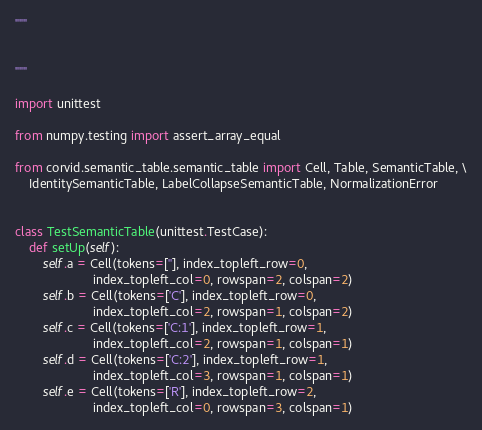<code> <loc_0><loc_0><loc_500><loc_500><_Python_>"""


"""

import unittest

from numpy.testing import assert_array_equal

from corvid.semantic_table.semantic_table import Cell, Table, SemanticTable, \
    IdentitySemanticTable, LabelCollapseSemanticTable, NormalizationError


class TestSemanticTable(unittest.TestCase):
    def setUp(self):
        self.a = Cell(tokens=[''], index_topleft_row=0,
                      index_topleft_col=0, rowspan=2, colspan=2)
        self.b = Cell(tokens=['C'], index_topleft_row=0,
                      index_topleft_col=2, rowspan=1, colspan=2)
        self.c = Cell(tokens=['C:1'], index_topleft_row=1,
                      index_topleft_col=2, rowspan=1, colspan=1)
        self.d = Cell(tokens=['C:2'], index_topleft_row=1,
                      index_topleft_col=3, rowspan=1, colspan=1)
        self.e = Cell(tokens=['R'], index_topleft_row=2,
                      index_topleft_col=0, rowspan=3, colspan=1)</code> 